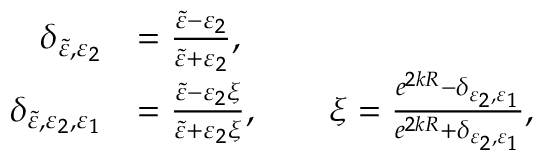Convert formula to latex. <formula><loc_0><loc_0><loc_500><loc_500>\begin{array} { r l } { \delta _ { \tilde { \varepsilon } , \varepsilon _ { 2 } } } & { = \frac { \tilde { \varepsilon } - \varepsilon _ { 2 } } { \tilde { \varepsilon } + \varepsilon _ { 2 } } , } \\ { \delta _ { \tilde { \varepsilon } , \varepsilon _ { 2 } , \varepsilon _ { 1 } } } & { = \frac { \tilde { \varepsilon } - \varepsilon _ { 2 } \xi } { \tilde { \varepsilon } + \varepsilon _ { 2 } \xi } , \quad \xi = \frac { e ^ { 2 k R } - \delta _ { \varepsilon _ { 2 } , \varepsilon _ { 1 } } } { e ^ { 2 k R } + \delta _ { \varepsilon _ { 2 } , \varepsilon _ { 1 } } } , } \end{array}</formula> 